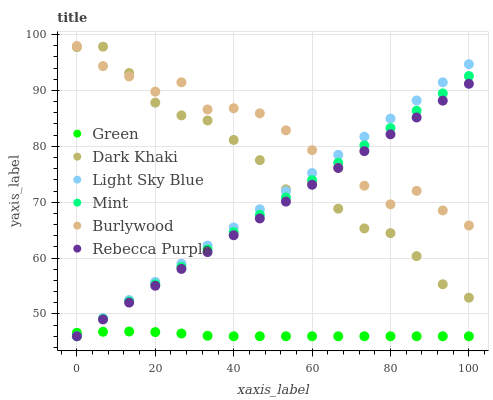Does Green have the minimum area under the curve?
Answer yes or no. Yes. Does Burlywood have the maximum area under the curve?
Answer yes or no. Yes. Does Dark Khaki have the minimum area under the curve?
Answer yes or no. No. Does Dark Khaki have the maximum area under the curve?
Answer yes or no. No. Is Light Sky Blue the smoothest?
Answer yes or no. Yes. Is Dark Khaki the roughest?
Answer yes or no. Yes. Is Dark Khaki the smoothest?
Answer yes or no. No. Is Light Sky Blue the roughest?
Answer yes or no. No. Does Light Sky Blue have the lowest value?
Answer yes or no. Yes. Does Dark Khaki have the lowest value?
Answer yes or no. No. Does Burlywood have the highest value?
Answer yes or no. Yes. Does Dark Khaki have the highest value?
Answer yes or no. No. Is Green less than Burlywood?
Answer yes or no. Yes. Is Burlywood greater than Green?
Answer yes or no. Yes. Does Rebecca Purple intersect Dark Khaki?
Answer yes or no. Yes. Is Rebecca Purple less than Dark Khaki?
Answer yes or no. No. Is Rebecca Purple greater than Dark Khaki?
Answer yes or no. No. Does Green intersect Burlywood?
Answer yes or no. No. 